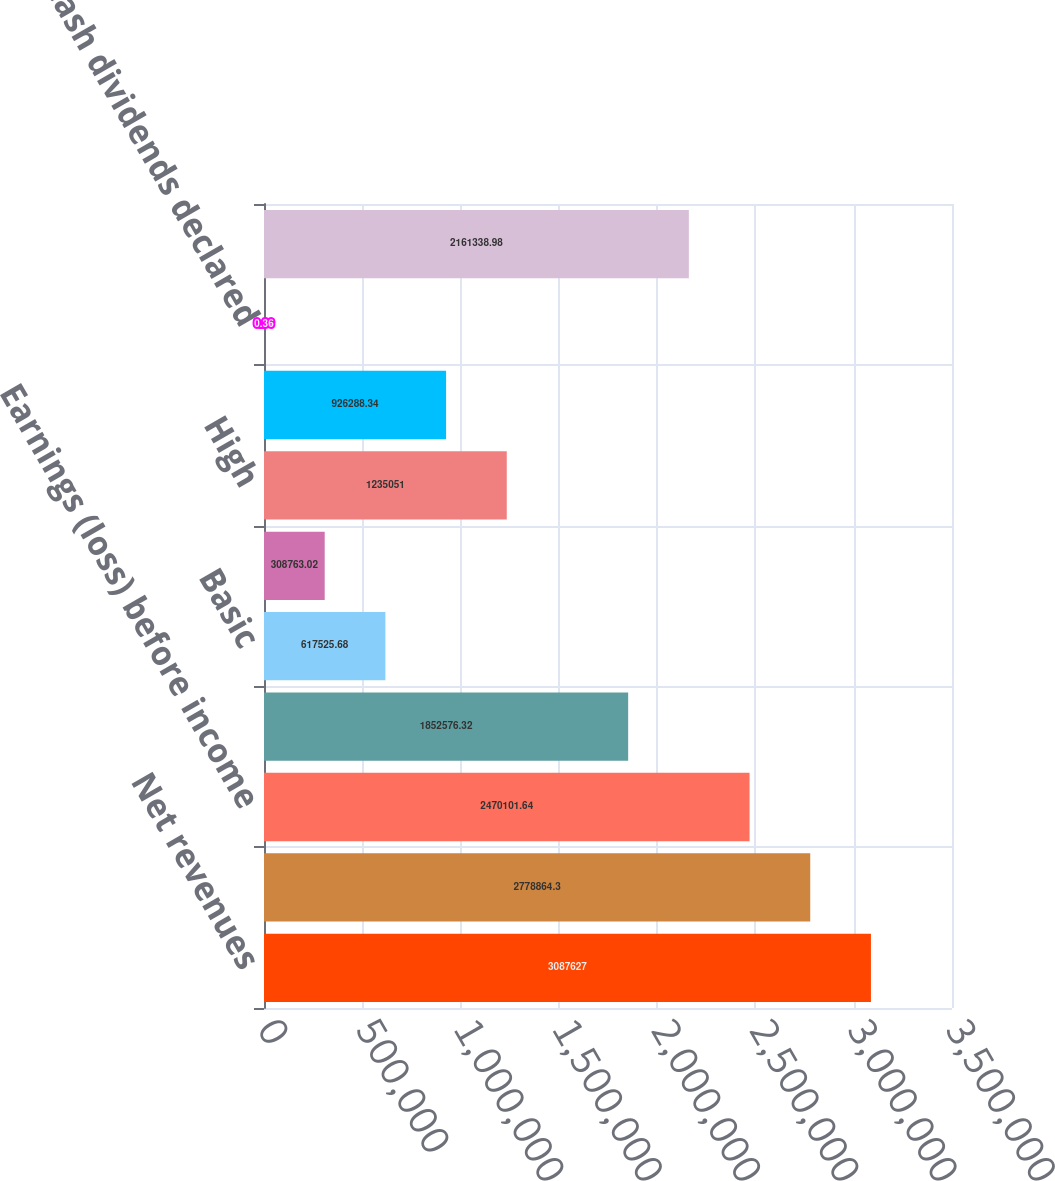Convert chart. <chart><loc_0><loc_0><loc_500><loc_500><bar_chart><fcel>Net revenues<fcel>Gross profit<fcel>Earnings (loss) before income<fcel>Net earnings (loss)<fcel>Basic<fcel>Diluted<fcel>High<fcel>Low<fcel>Cash dividends declared<fcel>Earnings before income taxes<nl><fcel>3.08763e+06<fcel>2.77886e+06<fcel>2.4701e+06<fcel>1.85258e+06<fcel>617526<fcel>308763<fcel>1.23505e+06<fcel>926288<fcel>0.36<fcel>2.16134e+06<nl></chart> 